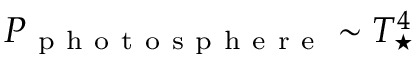<formula> <loc_0><loc_0><loc_500><loc_500>P _ { p h o t o s p h e r e } \sim T _ { ^ { * } } ^ { 4 }</formula> 